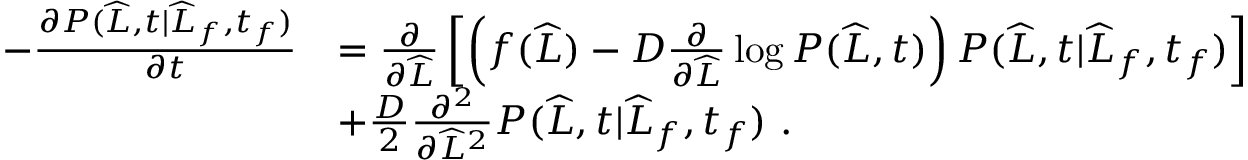<formula> <loc_0><loc_0><loc_500><loc_500>\begin{array} { r l } { - \frac { \partial P ( \widehat { L } , t | \widehat { L } _ { f } , t _ { f } ) } { \partial t } } & { = \frac { \partial } { \partial \widehat { L } } \left [ \left ( f ( \widehat { L } ) - D \frac { \partial } { \partial \widehat { L } } \log P ( \widehat { L } , t ) \right ) P ( \widehat { L } , t | \widehat { L } _ { f } , t _ { f } ) \right ] } \\ & { + \frac { D } { 2 } \frac { \partial ^ { 2 } } { \partial \widehat { L } ^ { 2 } } P ( \widehat { L } , t | \widehat { L } _ { f } , t _ { f } ) \ . } \end{array}</formula> 